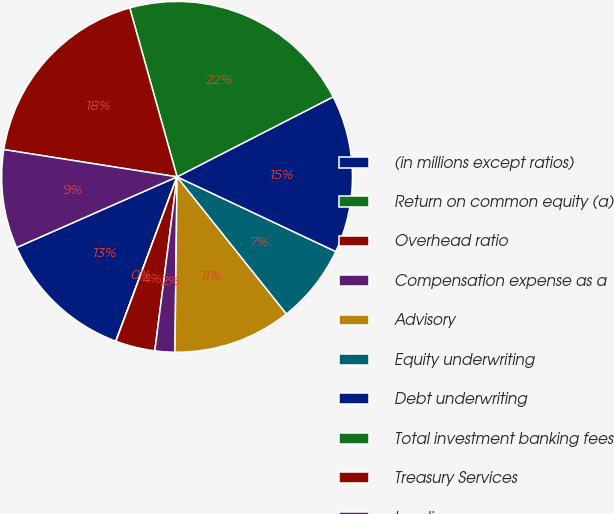Convert chart. <chart><loc_0><loc_0><loc_500><loc_500><pie_chart><fcel>(in millions except ratios)<fcel>Return on common equity (a)<fcel>Overhead ratio<fcel>Compensation expense as a<fcel>Advisory<fcel>Equity underwriting<fcel>Debt underwriting<fcel>Total investment banking fees<fcel>Treasury Services<fcel>Lending<nl><fcel>12.72%<fcel>0.01%<fcel>3.64%<fcel>1.83%<fcel>10.91%<fcel>7.28%<fcel>14.54%<fcel>21.81%<fcel>18.17%<fcel>9.09%<nl></chart> 